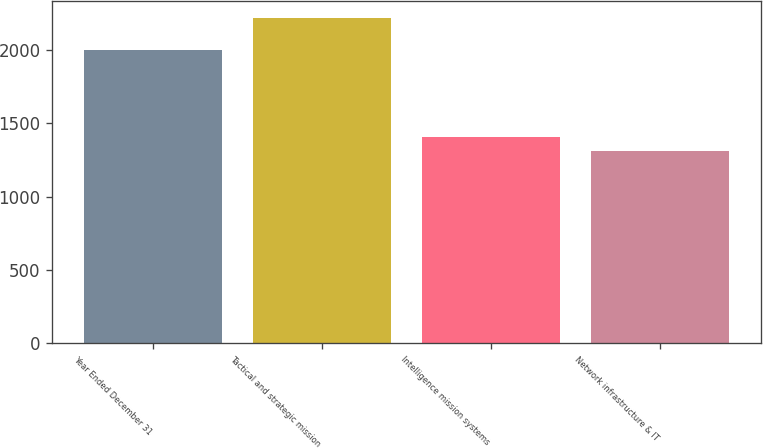Convert chart. <chart><loc_0><loc_0><loc_500><loc_500><bar_chart><fcel>Year Ended December 31<fcel>Tactical and strategic mission<fcel>Intelligence mission systems<fcel>Network infrastructure & IT<nl><fcel>2003<fcel>2221<fcel>1403.8<fcel>1313<nl></chart> 